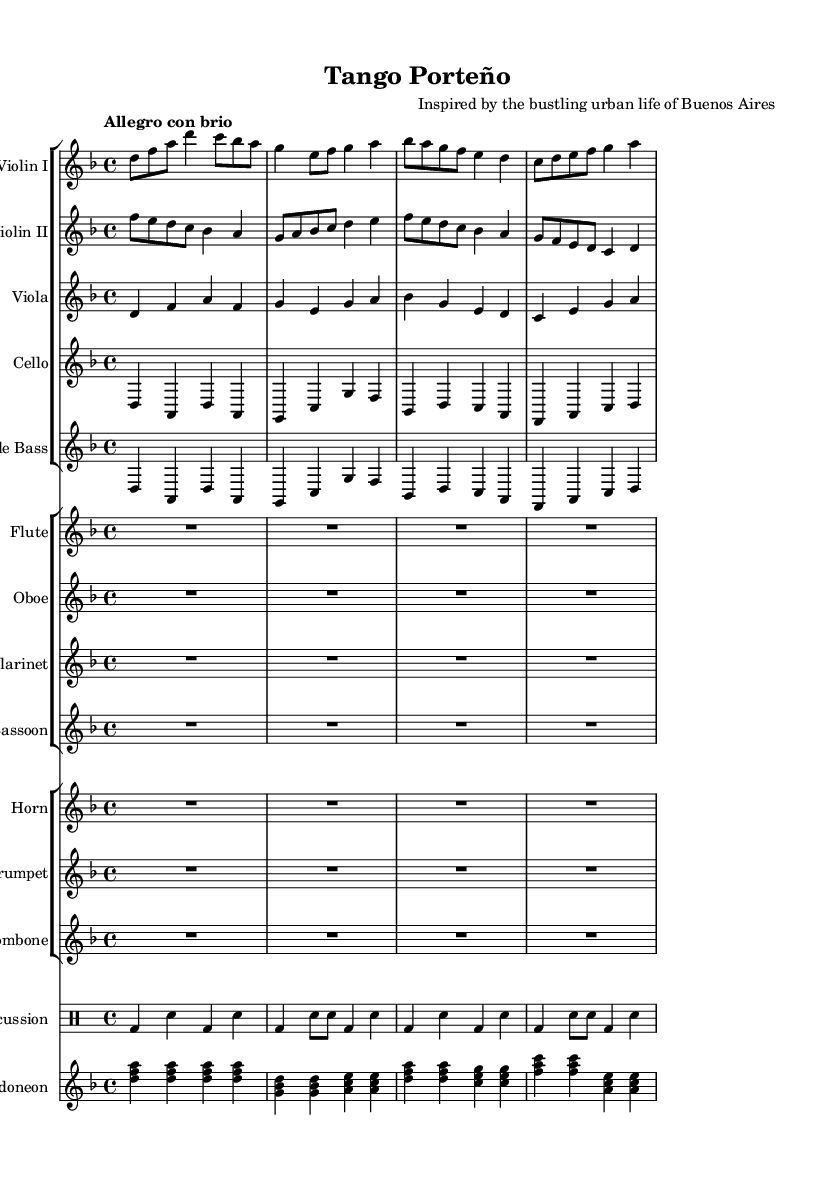What is the key signature of this music? The key signature is D minor, which has one flat (C). This is indicated at the beginning of the staff where the key signature is shown.
Answer: D minor What is the time signature of this music? The time signature is 4/4, which means there are four beats in each measure and the quarter note gets one beat. This is shown at the beginning of the piece in the notation.
Answer: 4/4 What is the tempo marking of this piece? The tempo marking is "Allegro con brio," which indicates a fast and lively pace. This is also indicated at the beginning of the score.
Answer: Allegro con brio Which instruments are featured in this symphony? The instruments scored include violins I and II, viola, cello, double bass, flute, oboe, clarinet, bassoon, horn, trumpet, trombone, percussion, and bandoneon. These are listed at the beginning of each staff in the score.
Answer: Violins, viola, cello, double bass, flute, oboe, clarinet, bassoon, horn, trumpet, trombone, percussion, bandoneon How many measures are in the violin I part? Count the measures in the music staff for violin I. Each line and space represents a measure, which can be counted. Upon counting, there are 8 measures present in this part.
Answer: 8 Which section of the orchestra plays the rhythmically pivotal percussion line? The percussion section is responsible for maintaining the rhythm and is indicated by the drum staff, which is a separate staff dedicated to percussion instruments.
Answer: Percussion What type of dance or musical style is this symphonic suite inspired by? The suite is inspired by the Tango, a dance very much associated with the cultural identity of Buenos Aires. This is inferred from the title "Tango Porteño."
Answer: Tango 